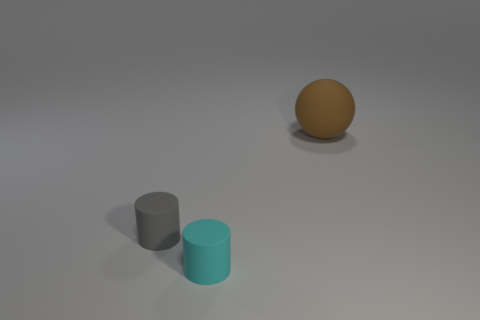Add 1 small cyan things. How many objects exist? 4 Subtract all cylinders. How many objects are left? 1 Subtract all brown cylinders. Subtract all cyan blocks. How many cylinders are left? 2 Add 2 gray cylinders. How many gray cylinders exist? 3 Subtract 1 cyan cylinders. How many objects are left? 2 Subtract all tiny cyan shiny things. Subtract all large brown matte objects. How many objects are left? 2 Add 3 cyan rubber things. How many cyan rubber things are left? 4 